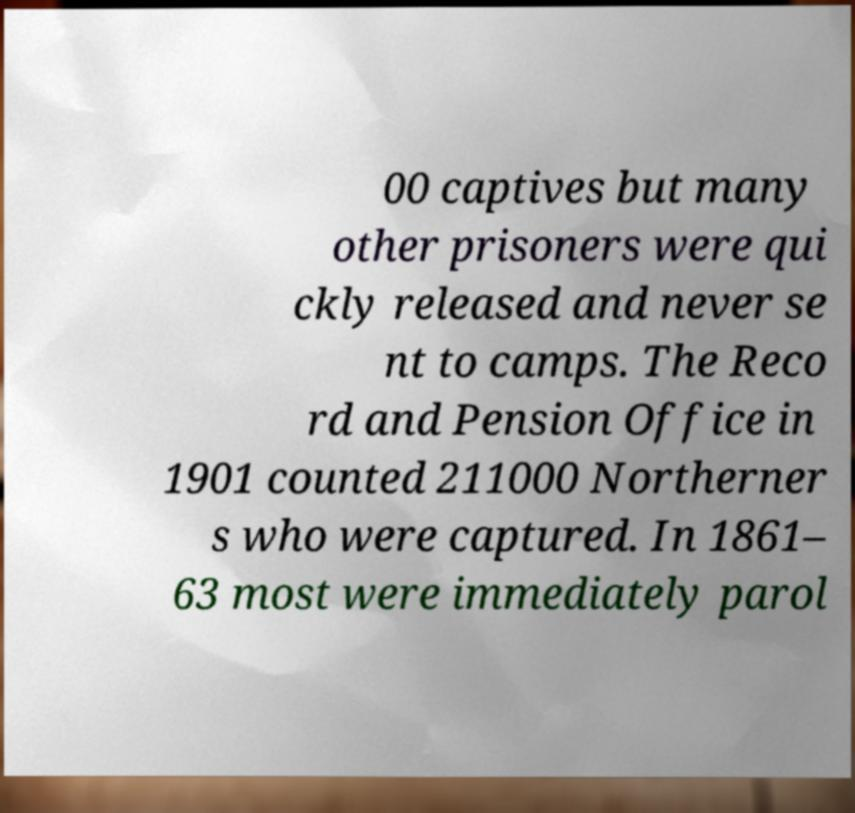Please read and relay the text visible in this image. What does it say? 00 captives but many other prisoners were qui ckly released and never se nt to camps. The Reco rd and Pension Office in 1901 counted 211000 Northerner s who were captured. In 1861– 63 most were immediately parol 